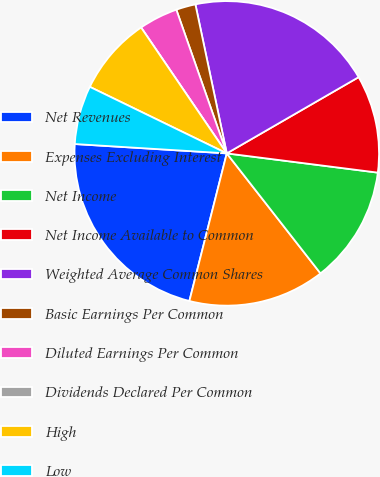<chart> <loc_0><loc_0><loc_500><loc_500><pie_chart><fcel>Net Revenues<fcel>Expenses Excluding Interest<fcel>Net Income<fcel>Net Income Available to Common<fcel>Weighted Average Common Shares<fcel>Basic Earnings Per Common<fcel>Diluted Earnings Per Common<fcel>Dividends Declared Per Common<fcel>High<fcel>Low<nl><fcel>22.03%<fcel>14.5%<fcel>12.43%<fcel>10.36%<fcel>19.96%<fcel>2.07%<fcel>4.14%<fcel>0.0%<fcel>8.29%<fcel>6.22%<nl></chart> 